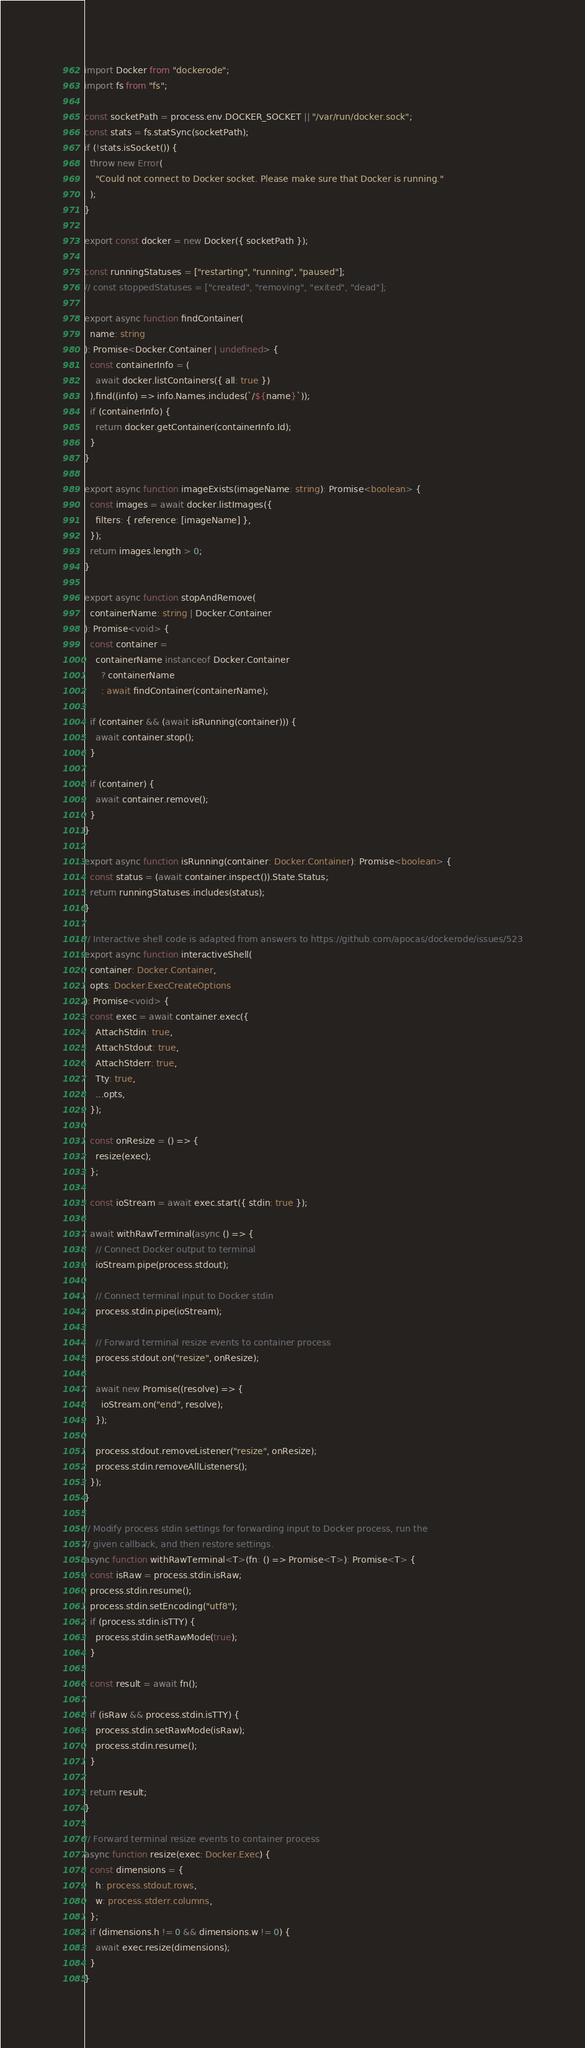Convert code to text. <code><loc_0><loc_0><loc_500><loc_500><_TypeScript_>import Docker from "dockerode";
import fs from "fs";

const socketPath = process.env.DOCKER_SOCKET || "/var/run/docker.sock";
const stats = fs.statSync(socketPath);
if (!stats.isSocket()) {
  throw new Error(
    "Could not connect to Docker socket. Please make sure that Docker is running."
  );
}

export const docker = new Docker({ socketPath });

const runningStatuses = ["restarting", "running", "paused"];
// const stoppedStatuses = ["created", "removing", "exited", "dead"];

export async function findContainer(
  name: string
): Promise<Docker.Container | undefined> {
  const containerInfo = (
    await docker.listContainers({ all: true })
  ).find((info) => info.Names.includes(`/${name}`));
  if (containerInfo) {
    return docker.getContainer(containerInfo.Id);
  }
}

export async function imageExists(imageName: string): Promise<boolean> {
  const images = await docker.listImages({
    filters: { reference: [imageName] },
  });
  return images.length > 0;
}

export async function stopAndRemove(
  containerName: string | Docker.Container
): Promise<void> {
  const container =
    containerName instanceof Docker.Container
      ? containerName
      : await findContainer(containerName);

  if (container && (await isRunning(container))) {
    await container.stop();
  }

  if (container) {
    await container.remove();
  }
}

export async function isRunning(container: Docker.Container): Promise<boolean> {
  const status = (await container.inspect()).State.Status;
  return runningStatuses.includes(status);
}

// Interactive shell code is adapted from answers to https://github.com/apocas/dockerode/issues/523
export async function interactiveShell(
  container: Docker.Container,
  opts: Docker.ExecCreateOptions
): Promise<void> {
  const exec = await container.exec({
    AttachStdin: true,
    AttachStdout: true,
    AttachStderr: true,
    Tty: true,
    ...opts,
  });

  const onResize = () => {
    resize(exec);
  };

  const ioStream = await exec.start({ stdin: true });

  await withRawTerminal(async () => {
    // Connect Docker output to terminal
    ioStream.pipe(process.stdout);

    // Connect terminal input to Docker stdin
    process.stdin.pipe(ioStream);

    // Forward terminal resize events to container process
    process.stdout.on("resize", onResize);

    await new Promise((resolve) => {
      ioStream.on("end", resolve);
    });

    process.stdout.removeListener("resize", onResize);
    process.stdin.removeAllListeners();
  });
}

// Modify process stdin settings for forwarding input to Docker process, run the
// given callback, and then restore settings.
async function withRawTerminal<T>(fn: () => Promise<T>): Promise<T> {
  const isRaw = process.stdin.isRaw;
  process.stdin.resume();
  process.stdin.setEncoding("utf8");
  if (process.stdin.isTTY) {
    process.stdin.setRawMode(true);
  }

  const result = await fn();

  if (isRaw && process.stdin.isTTY) {
    process.stdin.setRawMode(isRaw);
    process.stdin.resume();
  }

  return result;
}

// Forward terminal resize events to container process
async function resize(exec: Docker.Exec) {
  const dimensions = {
    h: process.stdout.rows,
    w: process.stderr.columns,
  };
  if (dimensions.h != 0 && dimensions.w != 0) {
    await exec.resize(dimensions);
  }
}
</code> 